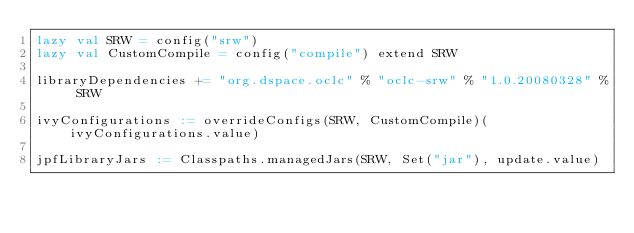<code> <loc_0><loc_0><loc_500><loc_500><_Scala_>lazy val SRW = config("srw")
lazy val CustomCompile = config("compile") extend SRW

libraryDependencies += "org.dspace.oclc" % "oclc-srw" % "1.0.20080328" % SRW

ivyConfigurations := overrideConfigs(SRW, CustomCompile)(ivyConfigurations.value)

jpfLibraryJars := Classpaths.managedJars(SRW, Set("jar"), update.value)



</code> 